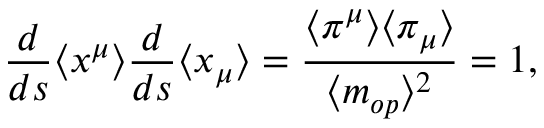Convert formula to latex. <formula><loc_0><loc_0><loc_500><loc_500>\frac { d } { d s } \langle x ^ { \mu } \rangle \frac { d } { d s } \langle x _ { \mu } \rangle = \frac { \langle \pi ^ { \mu } \rangle \langle \pi _ { \mu } \rangle } { \langle m _ { o p } \rangle ^ { 2 } } = 1 ,</formula> 